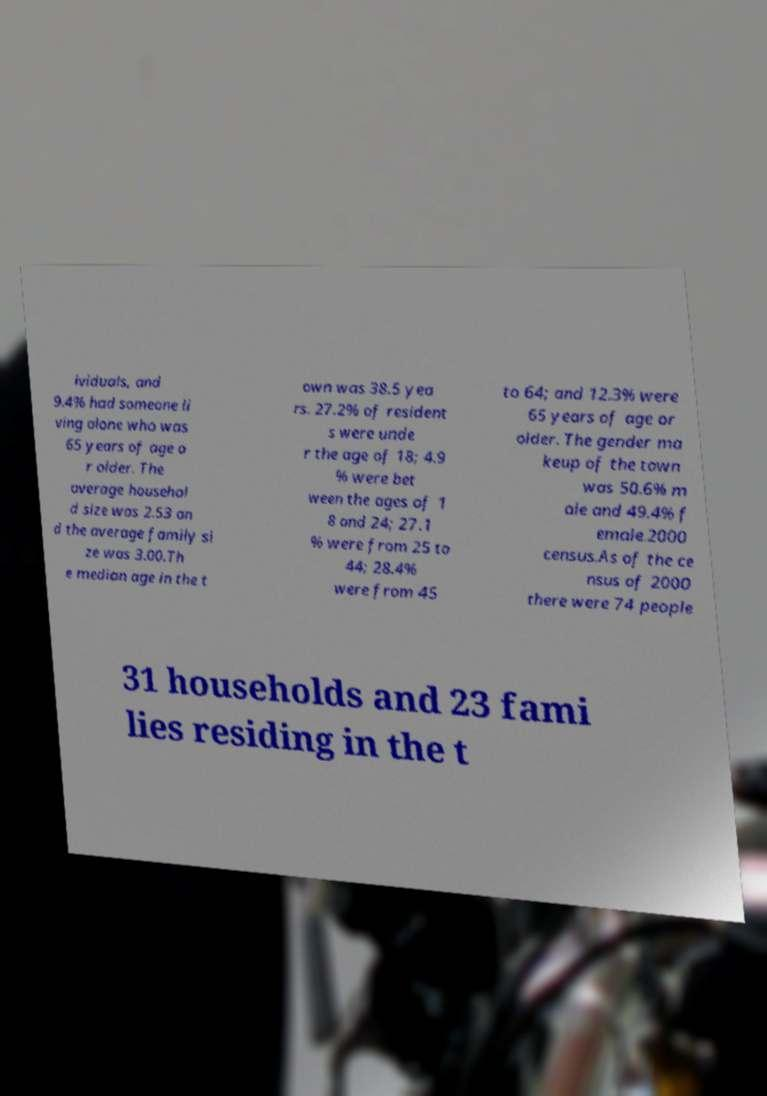Please read and relay the text visible in this image. What does it say? ividuals, and 9.4% had someone li ving alone who was 65 years of age o r older. The average househol d size was 2.53 an d the average family si ze was 3.00.Th e median age in the t own was 38.5 yea rs. 27.2% of resident s were unde r the age of 18; 4.9 % were bet ween the ages of 1 8 and 24; 27.1 % were from 25 to 44; 28.4% were from 45 to 64; and 12.3% were 65 years of age or older. The gender ma keup of the town was 50.6% m ale and 49.4% f emale.2000 census.As of the ce nsus of 2000 there were 74 people 31 households and 23 fami lies residing in the t 